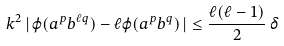<formula> <loc_0><loc_0><loc_500><loc_500>k ^ { 2 } \, | \, \varphi ( a ^ { p } b ^ { \ell q } ) - \ell \varphi ( a ^ { p } b ^ { q } ) \, | \leq \frac { \ell ( \ell - 1 ) } { 2 } \, \delta</formula> 